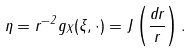<formula> <loc_0><loc_0><loc_500><loc_500>\eta = r ^ { - 2 } g _ { X } ( \xi , \cdot ) = J \left ( \frac { d r } { r } \right ) .</formula> 